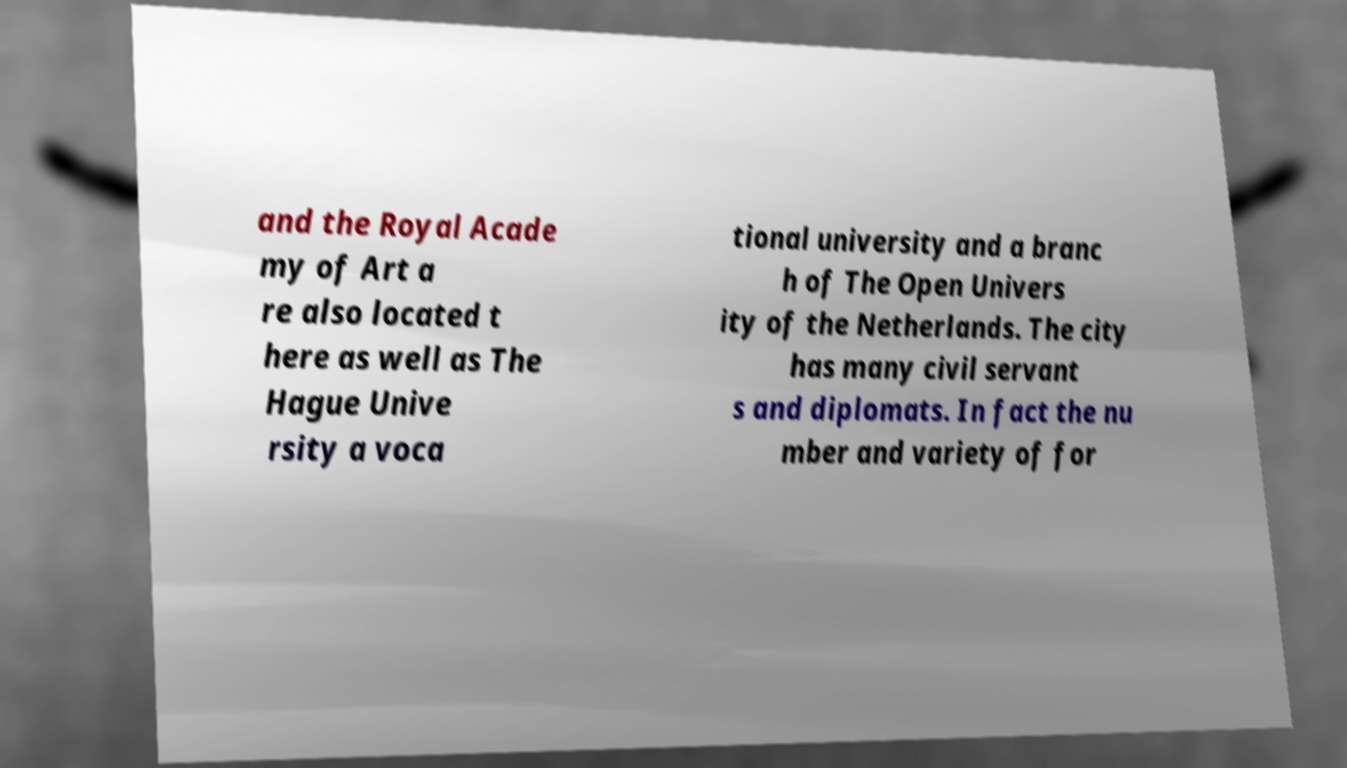There's text embedded in this image that I need extracted. Can you transcribe it verbatim? and the Royal Acade my of Art a re also located t here as well as The Hague Unive rsity a voca tional university and a branc h of The Open Univers ity of the Netherlands. The city has many civil servant s and diplomats. In fact the nu mber and variety of for 